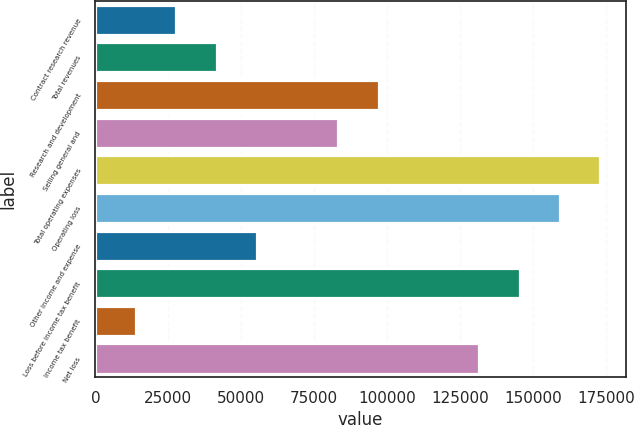Convert chart to OTSL. <chart><loc_0><loc_0><loc_500><loc_500><bar_chart><fcel>Contract research revenue<fcel>Total revenues<fcel>Research and development<fcel>Selling general and<fcel>Total operating expenses<fcel>Operating loss<fcel>Other income and expense<fcel>Loss before income tax benefit<fcel>Income tax benefit<fcel>Net loss<nl><fcel>27731.9<fcel>41595.8<fcel>97051.4<fcel>83187.5<fcel>173106<fcel>159242<fcel>55459.7<fcel>145378<fcel>13868<fcel>131514<nl></chart> 